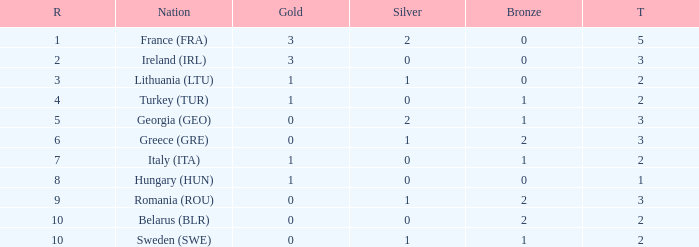Would you be able to parse every entry in this table? {'header': ['R', 'Nation', 'Gold', 'Silver', 'Bronze', 'T'], 'rows': [['1', 'France (FRA)', '3', '2', '0', '5'], ['2', 'Ireland (IRL)', '3', '0', '0', '3'], ['3', 'Lithuania (LTU)', '1', '1', '0', '2'], ['4', 'Turkey (TUR)', '1', '0', '1', '2'], ['5', 'Georgia (GEO)', '0', '2', '1', '3'], ['6', 'Greece (GRE)', '0', '1', '2', '3'], ['7', 'Italy (ITA)', '1', '0', '1', '2'], ['8', 'Hungary (HUN)', '1', '0', '0', '1'], ['9', 'Romania (ROU)', '0', '1', '2', '3'], ['10', 'Belarus (BLR)', '0', '0', '2', '2'], ['10', 'Sweden (SWE)', '0', '1', '1', '2']]} What's the rank of Turkey (TUR) with a total more than 2? 0.0. 